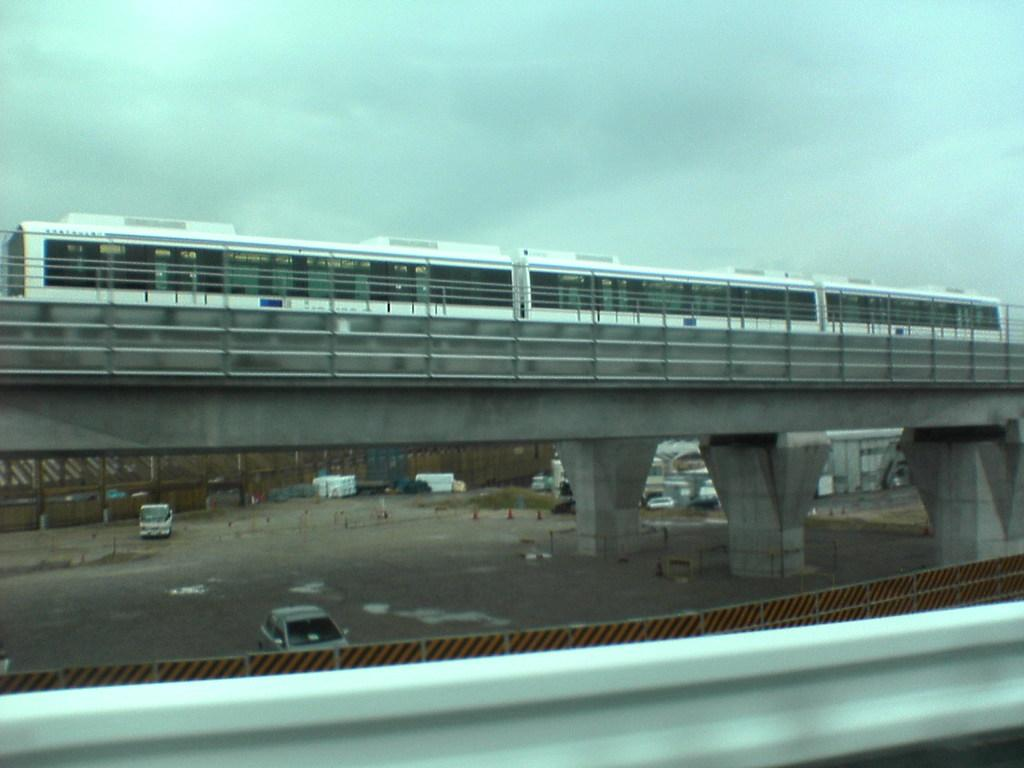Where was the image taken? The image was clicked outside. What can be seen in the middle of the image? There is a bridge in the middle of the image. What is on the bridge in the image? A train is present on the bridge. What type of vehicles can be seen at the bottom of the image? There are cars visible at the bottom of the image. What is visible at the top of the image? The sky is visible at the top of the image. What type of bear can be seen interacting with the train on the bridge? There is no bear present in the image; it features a train on a bridge with cars visible at the bottom. What is the texture of the train in the image? The texture of the train cannot be determined from the image alone, as it is a two-dimensional representation. 